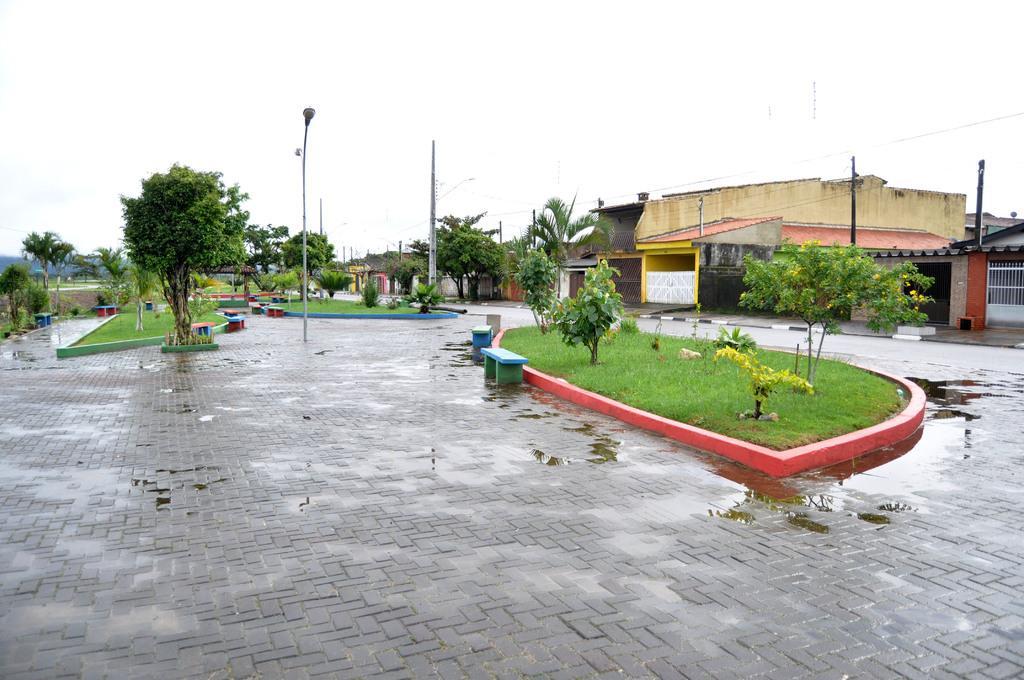Describe this image in one or two sentences. In this image we can see buildings, street poles, street lights, electric cables, trees, benches, floor, water, grill, hills and sky. 